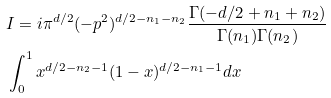<formula> <loc_0><loc_0><loc_500><loc_500>& I = i \pi ^ { d / 2 } ( - p ^ { 2 } ) ^ { d / 2 - n _ { 1 } - n _ { 2 } } \frac { \Gamma ( - d / 2 + n _ { 1 } + n _ { 2 } ) } { \Gamma ( n _ { 1 } ) \Gamma ( n _ { 2 } ) } \\ & \int _ { 0 } ^ { 1 } x ^ { d / 2 - n _ { 2 } - 1 } ( 1 - x ) ^ { d / 2 - n _ { 1 } - 1 } d x</formula> 